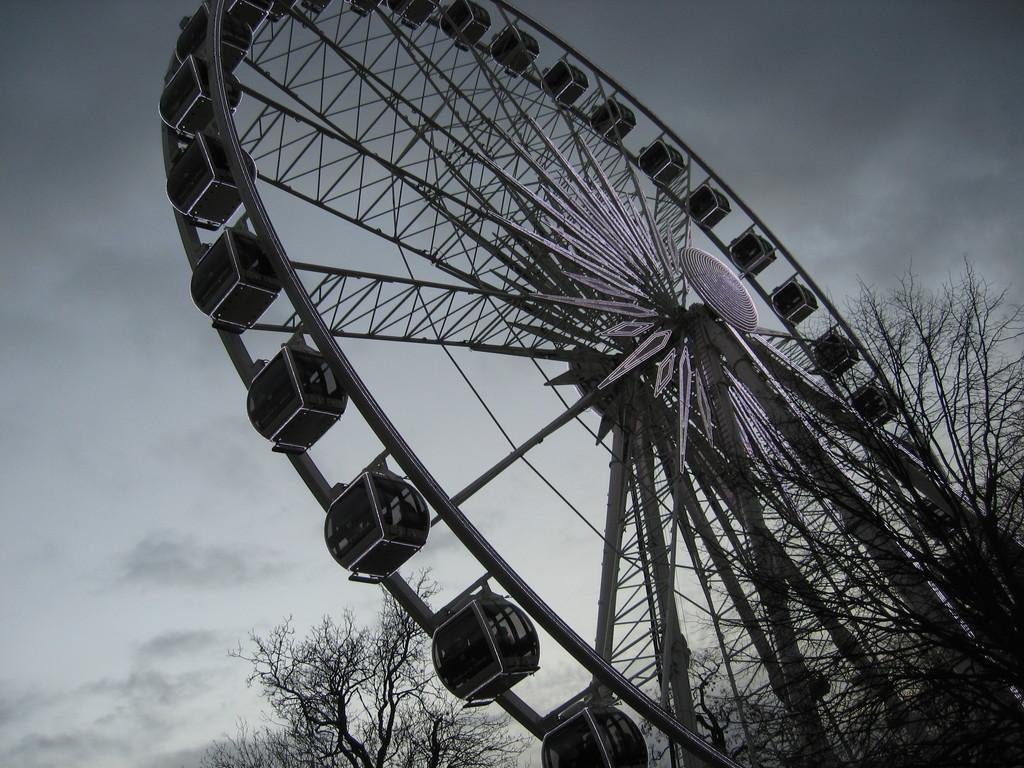What is the main subject of the image? There is a giant wheel in the image. What can be seen in the background of the image? There are dried trees in the background of the image. How would you describe the color of the sky in the image? The sky is gray in color. What type of mint is being used to flavor the shirt in the image? There is no mint or shirt present in the image; it only features a giant wheel and dried trees in the background. 